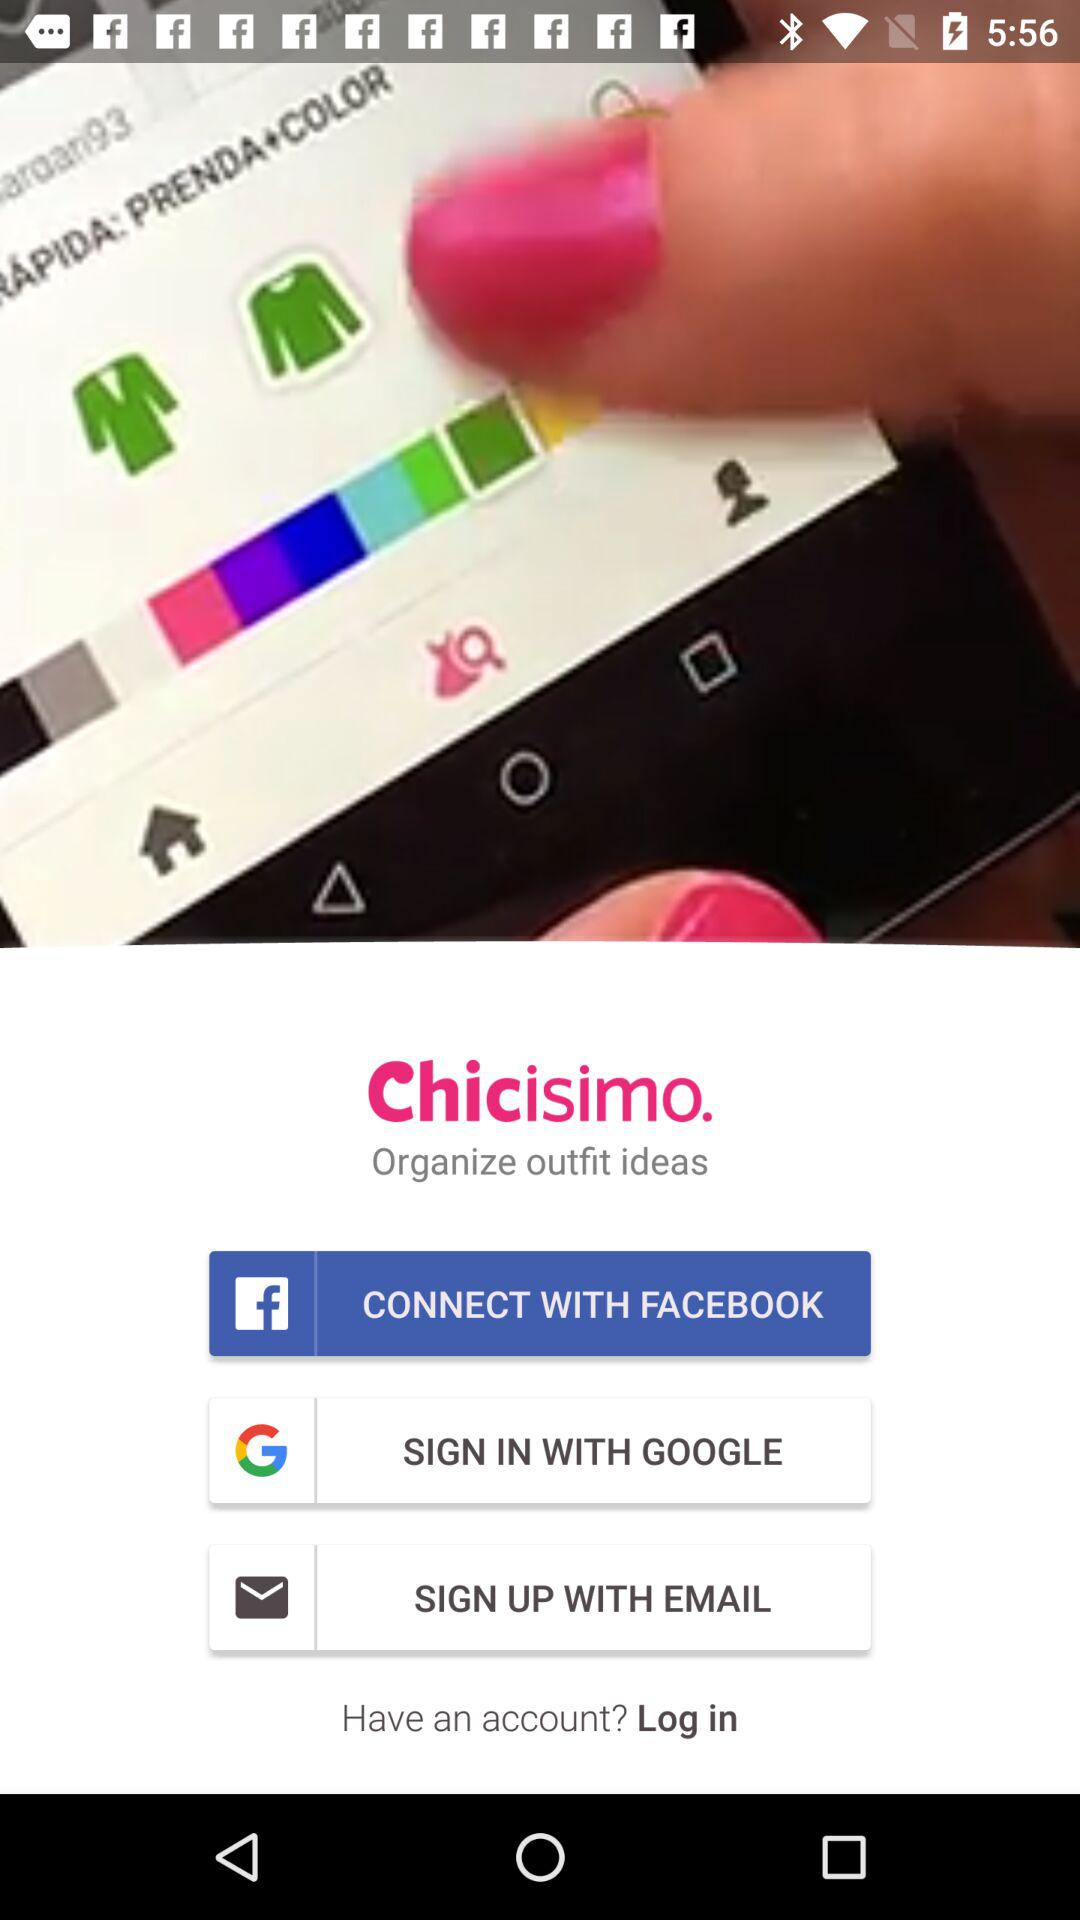What are the options given for logging in? The given options are "FACEBOOK", "GOOGLE" and "EMAIL". 